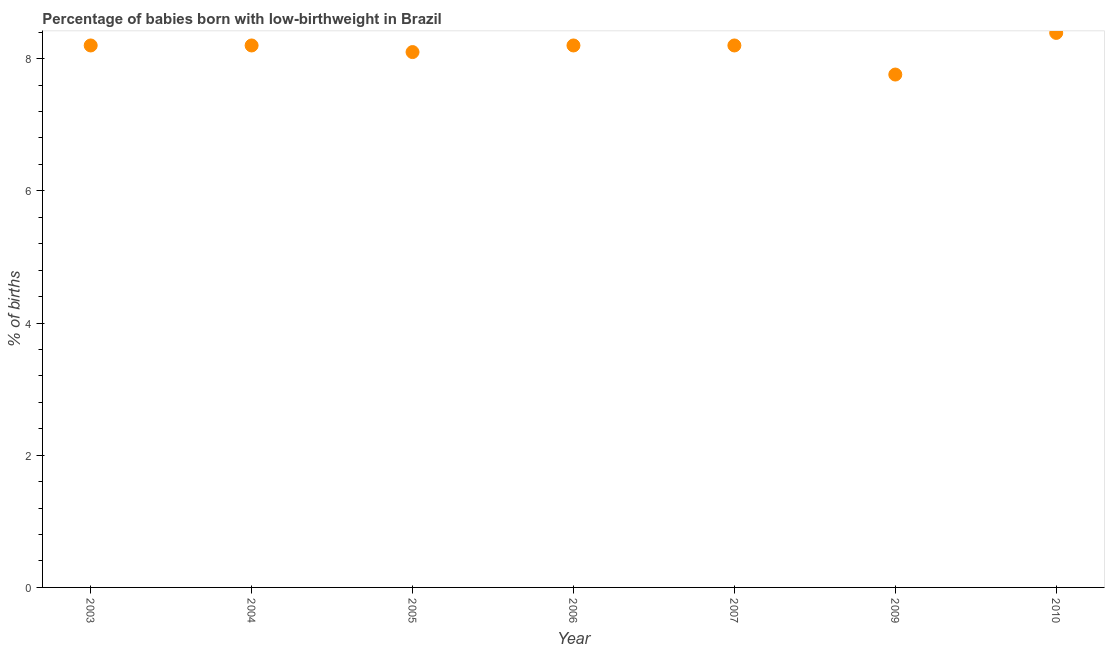What is the percentage of babies who were born with low-birthweight in 2007?
Keep it short and to the point. 8.2. Across all years, what is the maximum percentage of babies who were born with low-birthweight?
Offer a very short reply. 8.39. Across all years, what is the minimum percentage of babies who were born with low-birthweight?
Give a very brief answer. 7.76. In which year was the percentage of babies who were born with low-birthweight maximum?
Keep it short and to the point. 2010. In which year was the percentage of babies who were born with low-birthweight minimum?
Give a very brief answer. 2009. What is the sum of the percentage of babies who were born with low-birthweight?
Your response must be concise. 57.05. What is the difference between the percentage of babies who were born with low-birthweight in 2005 and 2009?
Provide a succinct answer. 0.34. What is the average percentage of babies who were born with low-birthweight per year?
Your answer should be very brief. 8.15. What is the median percentage of babies who were born with low-birthweight?
Make the answer very short. 8.2. Do a majority of the years between 2009 and 2006 (inclusive) have percentage of babies who were born with low-birthweight greater than 0.8 %?
Ensure brevity in your answer.  No. What is the ratio of the percentage of babies who were born with low-birthweight in 2005 to that in 2010?
Provide a short and direct response. 0.97. Is the percentage of babies who were born with low-birthweight in 2005 less than that in 2010?
Make the answer very short. Yes. Is the difference between the percentage of babies who were born with low-birthweight in 2004 and 2007 greater than the difference between any two years?
Give a very brief answer. No. What is the difference between the highest and the second highest percentage of babies who were born with low-birthweight?
Your answer should be compact. 0.19. What is the difference between the highest and the lowest percentage of babies who were born with low-birthweight?
Provide a short and direct response. 0.63. In how many years, is the percentage of babies who were born with low-birthweight greater than the average percentage of babies who were born with low-birthweight taken over all years?
Your answer should be compact. 5. How many dotlines are there?
Give a very brief answer. 1. How many years are there in the graph?
Provide a succinct answer. 7. Does the graph contain any zero values?
Offer a very short reply. No. What is the title of the graph?
Your response must be concise. Percentage of babies born with low-birthweight in Brazil. What is the label or title of the X-axis?
Offer a terse response. Year. What is the label or title of the Y-axis?
Ensure brevity in your answer.  % of births. What is the % of births in 2005?
Offer a terse response. 8.1. What is the % of births in 2007?
Give a very brief answer. 8.2. What is the % of births in 2009?
Offer a very short reply. 7.76. What is the % of births in 2010?
Provide a short and direct response. 8.39. What is the difference between the % of births in 2003 and 2004?
Offer a terse response. 0. What is the difference between the % of births in 2003 and 2006?
Ensure brevity in your answer.  0. What is the difference between the % of births in 2003 and 2007?
Give a very brief answer. 0. What is the difference between the % of births in 2003 and 2009?
Your answer should be compact. 0.44. What is the difference between the % of births in 2003 and 2010?
Offer a very short reply. -0.19. What is the difference between the % of births in 2004 and 2006?
Your response must be concise. 0. What is the difference between the % of births in 2004 and 2009?
Your answer should be compact. 0.44. What is the difference between the % of births in 2004 and 2010?
Your answer should be compact. -0.19. What is the difference between the % of births in 2005 and 2006?
Keep it short and to the point. -0.1. What is the difference between the % of births in 2005 and 2007?
Provide a short and direct response. -0.1. What is the difference between the % of births in 2005 and 2009?
Make the answer very short. 0.34. What is the difference between the % of births in 2005 and 2010?
Provide a succinct answer. -0.29. What is the difference between the % of births in 2006 and 2007?
Ensure brevity in your answer.  0. What is the difference between the % of births in 2006 and 2009?
Provide a short and direct response. 0.44. What is the difference between the % of births in 2006 and 2010?
Provide a succinct answer. -0.19. What is the difference between the % of births in 2007 and 2009?
Offer a very short reply. 0.44. What is the difference between the % of births in 2007 and 2010?
Your response must be concise. -0.19. What is the difference between the % of births in 2009 and 2010?
Your response must be concise. -0.63. What is the ratio of the % of births in 2003 to that in 2006?
Your answer should be compact. 1. What is the ratio of the % of births in 2003 to that in 2009?
Keep it short and to the point. 1.06. What is the ratio of the % of births in 2003 to that in 2010?
Provide a succinct answer. 0.98. What is the ratio of the % of births in 2004 to that in 2005?
Offer a very short reply. 1.01. What is the ratio of the % of births in 2004 to that in 2006?
Keep it short and to the point. 1. What is the ratio of the % of births in 2004 to that in 2007?
Keep it short and to the point. 1. What is the ratio of the % of births in 2004 to that in 2009?
Ensure brevity in your answer.  1.06. What is the ratio of the % of births in 2004 to that in 2010?
Offer a very short reply. 0.98. What is the ratio of the % of births in 2005 to that in 2007?
Ensure brevity in your answer.  0.99. What is the ratio of the % of births in 2005 to that in 2009?
Provide a short and direct response. 1.04. What is the ratio of the % of births in 2006 to that in 2007?
Your answer should be compact. 1. What is the ratio of the % of births in 2006 to that in 2009?
Your answer should be very brief. 1.06. What is the ratio of the % of births in 2007 to that in 2009?
Ensure brevity in your answer.  1.06. What is the ratio of the % of births in 2009 to that in 2010?
Offer a terse response. 0.93. 